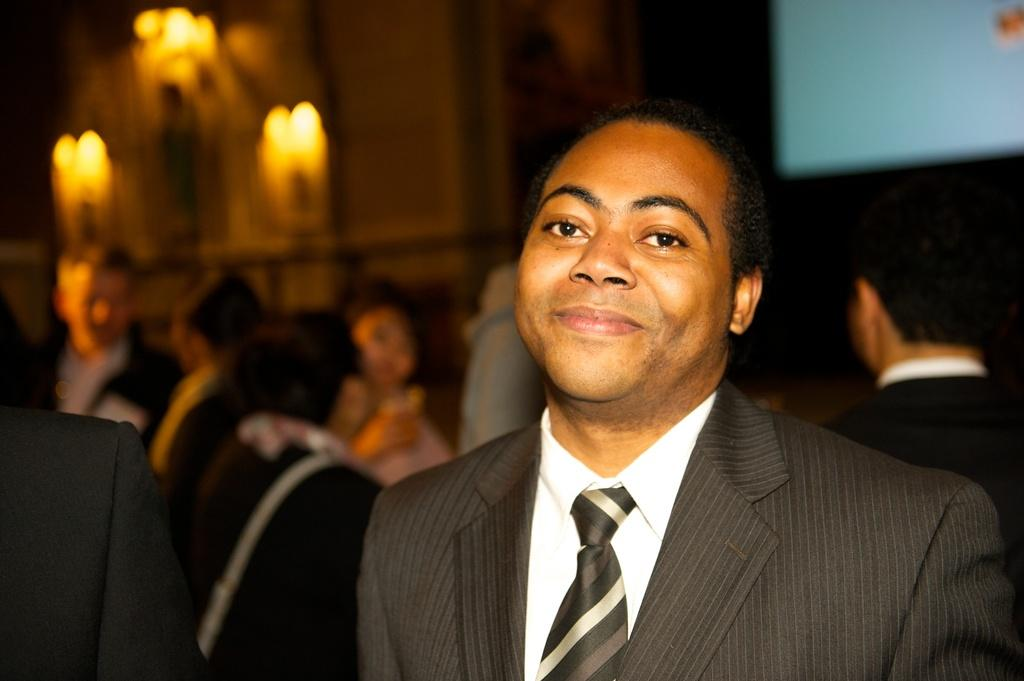How many people are in the image? There are people in the image, but the exact number is not specified. What can be seen in the image besides the people? There are lights, a screen, and a wall visible in the image. What is the person standing in the front wearing? The person standing in the front is wearing a black color jacket. What type of business is being conducted in the image? There is no indication of any business being conducted in the image. Can you tell me what type of machine is being used in the image? There is no machine present in the image. 